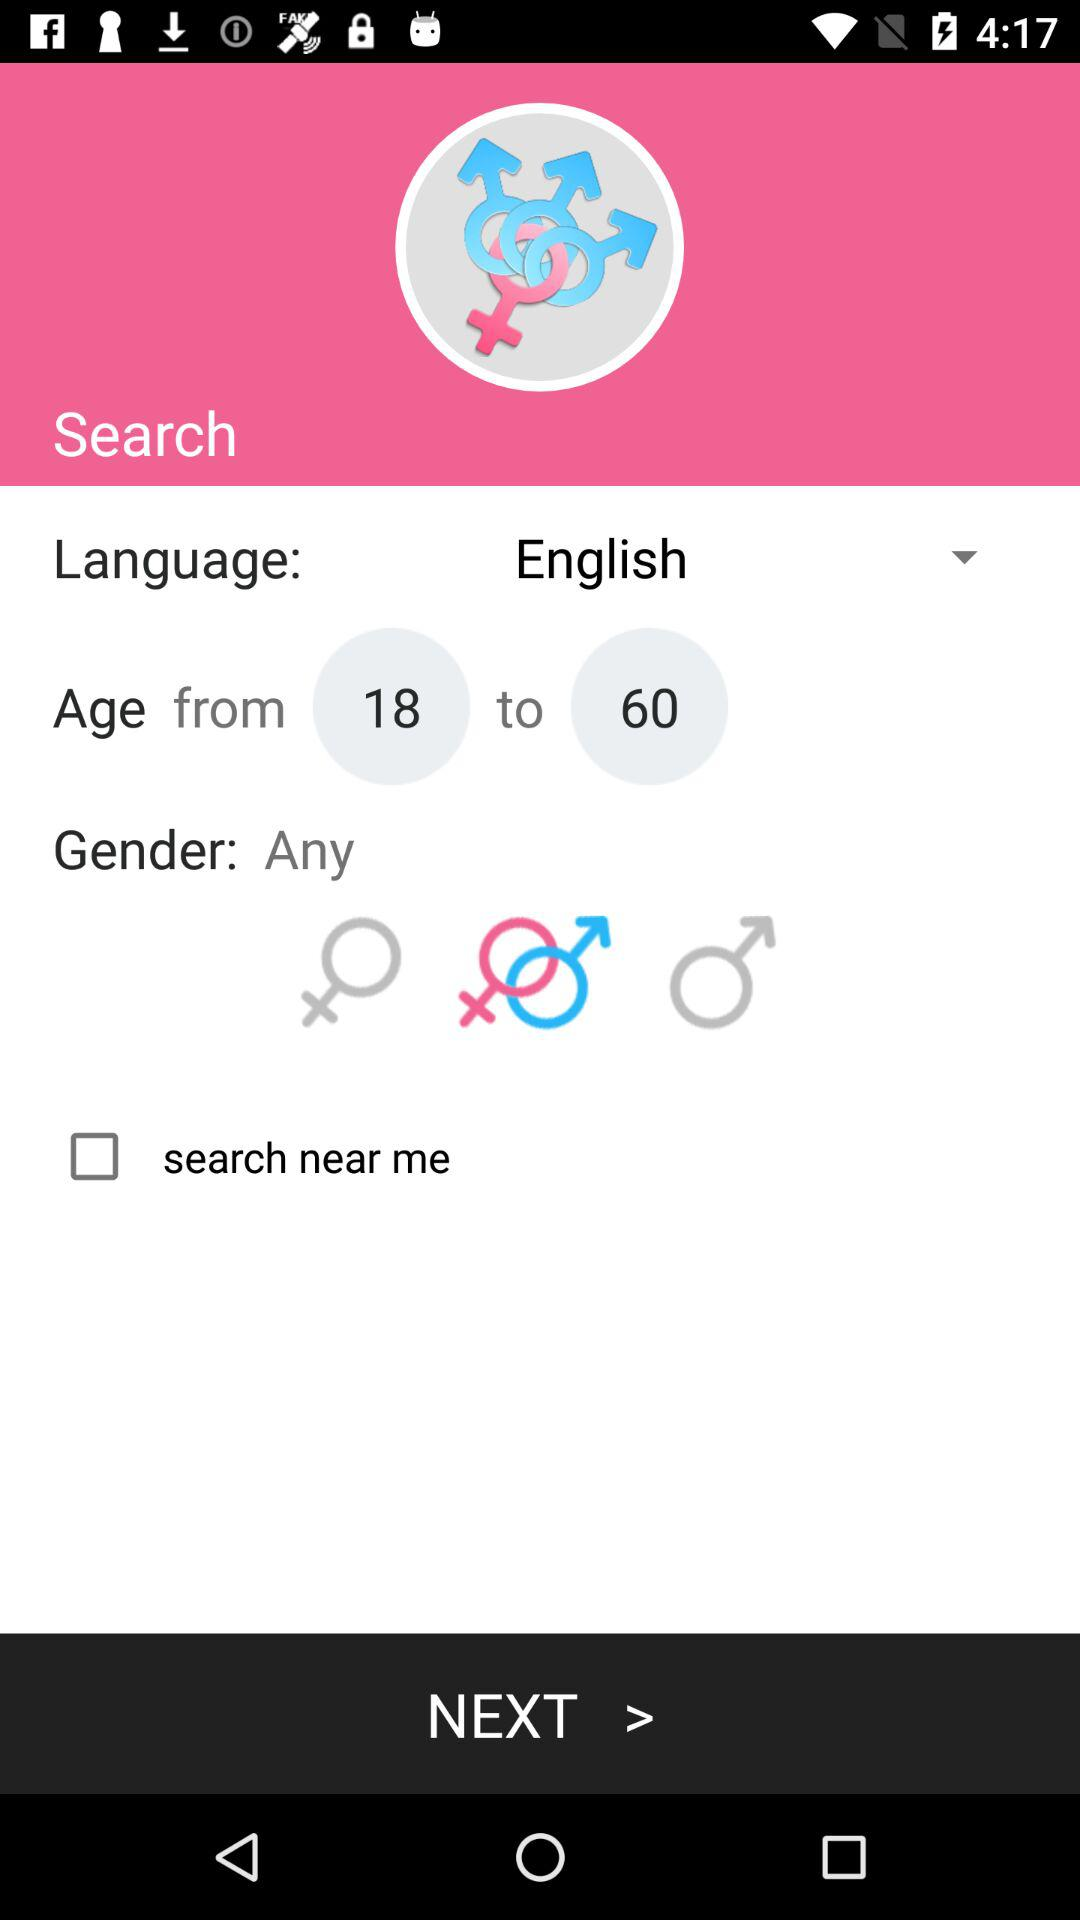How many people are near me?
When the provided information is insufficient, respond with <no answer>. <no answer> 